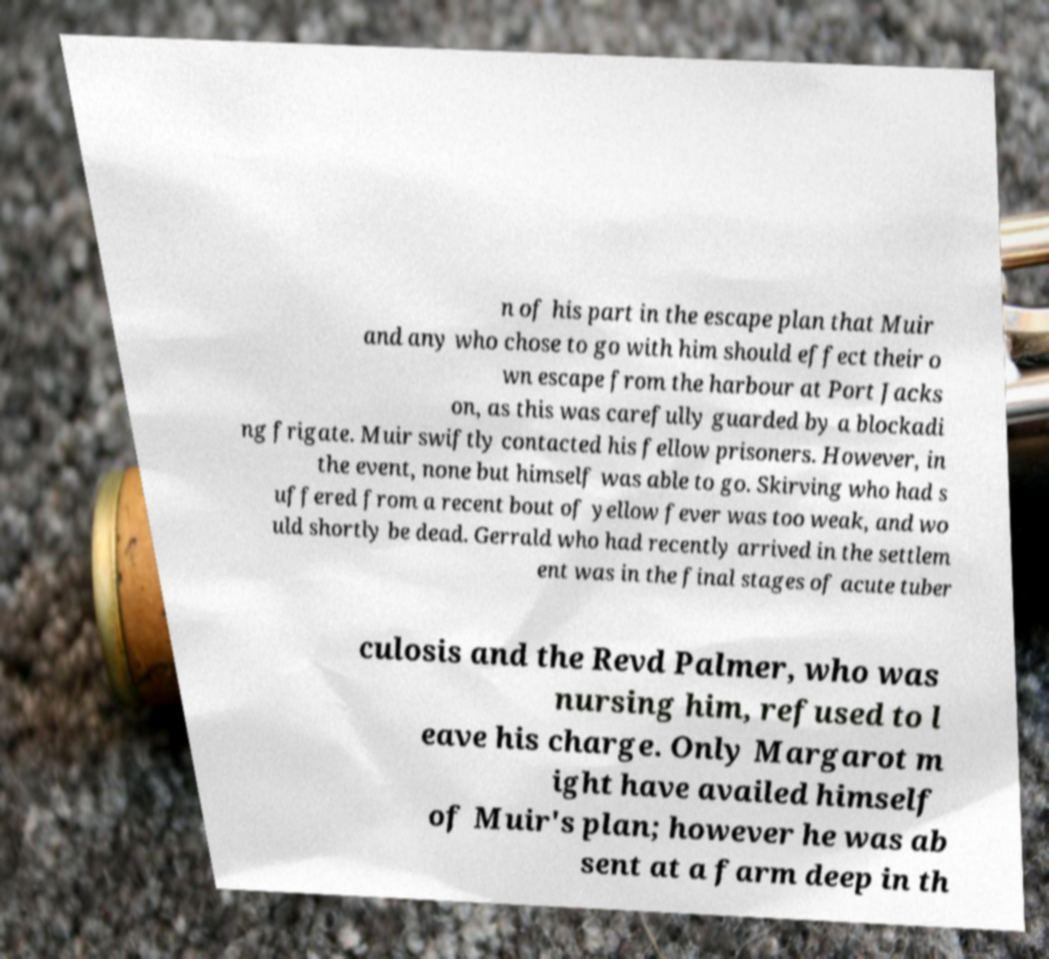Please read and relay the text visible in this image. What does it say? n of his part in the escape plan that Muir and any who chose to go with him should effect their o wn escape from the harbour at Port Jacks on, as this was carefully guarded by a blockadi ng frigate. Muir swiftly contacted his fellow prisoners. However, in the event, none but himself was able to go. Skirving who had s uffered from a recent bout of yellow fever was too weak, and wo uld shortly be dead. Gerrald who had recently arrived in the settlem ent was in the final stages of acute tuber culosis and the Revd Palmer, who was nursing him, refused to l eave his charge. Only Margarot m ight have availed himself of Muir's plan; however he was ab sent at a farm deep in th 